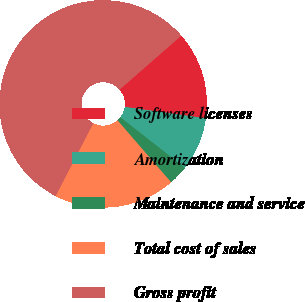<chart> <loc_0><loc_0><loc_500><loc_500><pie_chart><fcel>Software licenses<fcel>Amortization<fcel>Maintenance and service<fcel>Total cost of sales<fcel>Gross profit<nl><fcel>13.65%<fcel>8.36%<fcel>3.07%<fcel>18.94%<fcel>55.99%<nl></chart> 